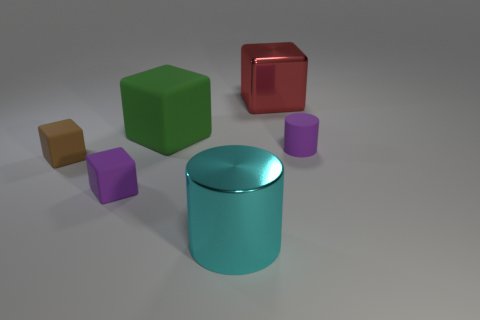Subtract all cyan blocks. Subtract all blue cylinders. How many blocks are left? 4 Add 1 brown things. How many objects exist? 7 Subtract all cylinders. How many objects are left? 4 Add 5 red things. How many red things are left? 6 Add 4 big red things. How many big red things exist? 5 Subtract 0 gray blocks. How many objects are left? 6 Subtract all tiny brown matte objects. Subtract all small purple matte cylinders. How many objects are left? 4 